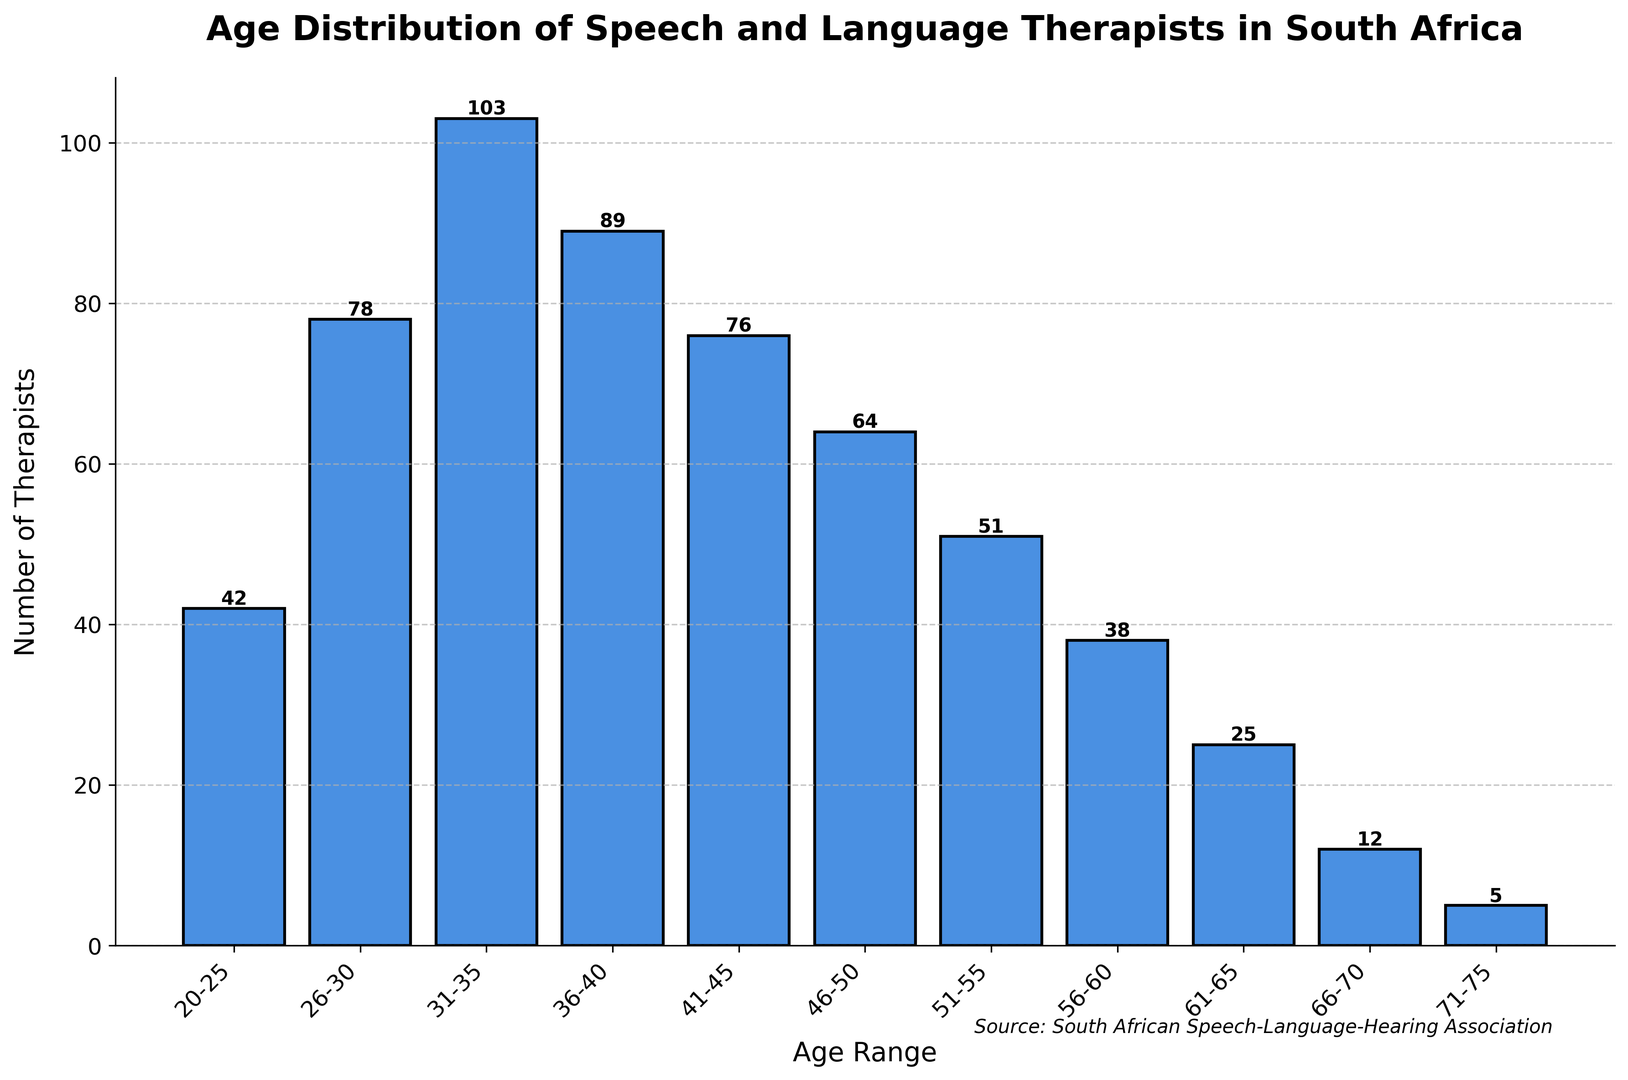What age range has the highest number of speech and language therapists in South Africa? By looking at the histogram, we can see which bar has the highest value. The highest bar represents the age range of 31-35 with a count of 103.
Answer: 31-35 How many speech and language therapists are aged between 36 and 45? We need to sum the counts from the age ranges of 36-40 and 41-45. From the histogram, these values are 89 (36-40) and 76 (41-45). So, 89 + 76 = 165.
Answer: 165 What is the difference in the number of therapists between the age ranges 26-30 and 66-70? According to the histogram, the number of therapists for 26-30 is 78 and for 66-70 is 12. The difference is 78 - 12 = 66.
Answer: 66 What's the average number of therapists across all age ranges? Sum all the counts from the histogram and divide by the number of age ranges. The counts sum to 42+78+103+89+76+64+51+38+25+12+5 = 583. There are 11 age ranges, hence 583 / 11 ≈ 53.
Answer: 53 Which age group has fewer therapists, 61-65 or 71-75? From the histogram, 61-65 has 25 therapists, and 71-75 has 5 therapists. 5 is less than 25.
Answer: 71-75 How many more therapists are there in the age range 31-35 compared to 51-55? From the histogram, there are 103 therapists in the 31-35 range and 51 therapists in the 51-55 range. The difference is 103 - 51 = 52.
Answer: 52 Is the number of therapists in the age range 56-60 greater than 61-65? The histogram shows 38 therapists in 56-60 and 25 in 61-65. 38 is greater than 25.
Answer: Yes What's the trend in the number of therapists from the age range 20-25 to 31-35? By observing the heights of the bars from the histogram, we see an increasing trend: 42 for 20-25, 78 for 26-30, and 103 for 31-35.
Answer: Increasing Is the number of therapists aged 46-50 closer to 41-45 or 51-55? From the histogram, 41-45 has 76 therapists, 46-50 has 64, and 51-55 has 51. The difference from 46-50 to 41-45 is 76 - 64 = 12, and to 51-55 is 64 - 51 = 13. The number is closer to 41-45.
Answer: 41-45 What percentage of therapists are aged 31-35? First, calculate the percentage using the count for 31-35 and total counts. (103 / 583) * 100 ≈ 17.67%.
Answer: 17.67% 